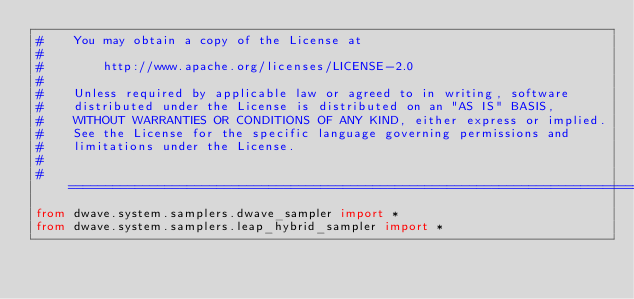<code> <loc_0><loc_0><loc_500><loc_500><_Python_>#    You may obtain a copy of the License at
#
#        http://www.apache.org/licenses/LICENSE-2.0
#
#    Unless required by applicable law or agreed to in writing, software
#    distributed under the License is distributed on an "AS IS" BASIS,
#    WITHOUT WARRANTIES OR CONDITIONS OF ANY KIND, either express or implied.
#    See the License for the specific language governing permissions and
#    limitations under the License.
#
# ================================================================================================
from dwave.system.samplers.dwave_sampler import *
from dwave.system.samplers.leap_hybrid_sampler import *
</code> 